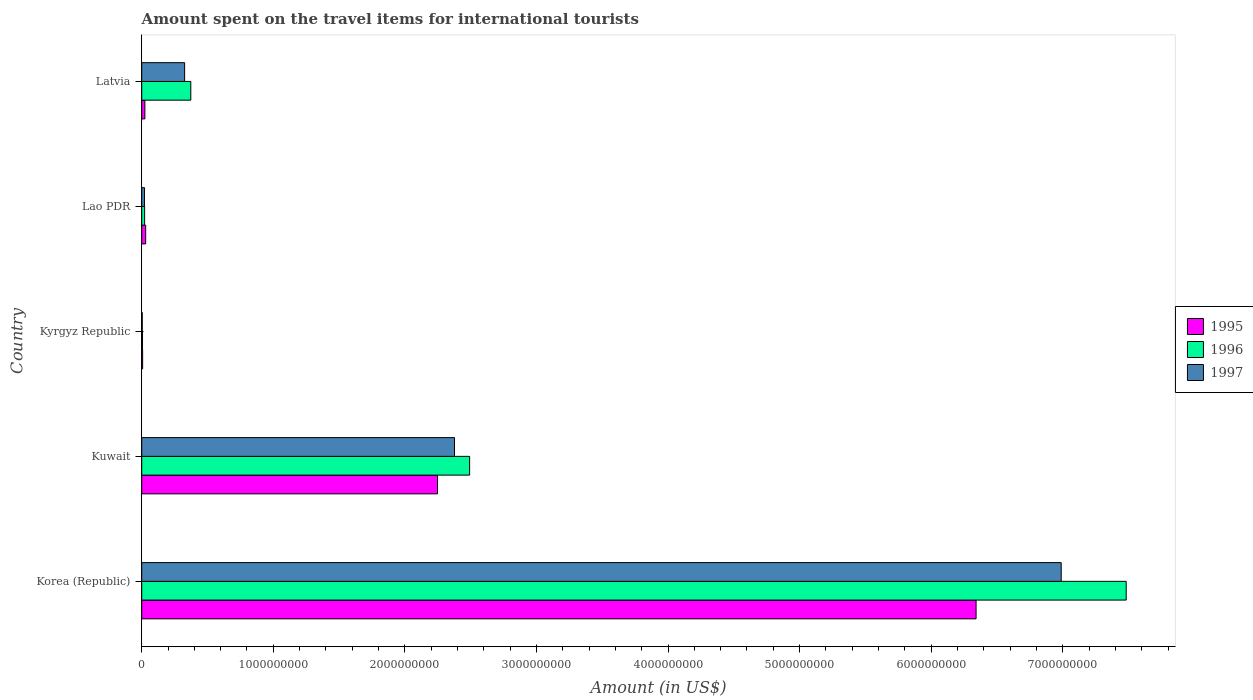How many different coloured bars are there?
Offer a terse response. 3. How many groups of bars are there?
Offer a very short reply. 5. Are the number of bars on each tick of the Y-axis equal?
Keep it short and to the point. Yes. How many bars are there on the 3rd tick from the top?
Provide a short and direct response. 3. What is the label of the 4th group of bars from the top?
Your response must be concise. Kuwait. What is the amount spent on the travel items for international tourists in 1997 in Kyrgyz Republic?
Keep it short and to the point. 4.00e+06. Across all countries, what is the maximum amount spent on the travel items for international tourists in 1996?
Offer a very short reply. 7.48e+09. Across all countries, what is the minimum amount spent on the travel items for international tourists in 1995?
Your answer should be very brief. 7.00e+06. In which country was the amount spent on the travel items for international tourists in 1997 maximum?
Your answer should be very brief. Korea (Republic). In which country was the amount spent on the travel items for international tourists in 1995 minimum?
Keep it short and to the point. Kyrgyz Republic. What is the total amount spent on the travel items for international tourists in 1995 in the graph?
Your response must be concise. 8.65e+09. What is the difference between the amount spent on the travel items for international tourists in 1996 in Kyrgyz Republic and that in Latvia?
Your answer should be compact. -3.67e+08. What is the difference between the amount spent on the travel items for international tourists in 1997 in Kuwait and the amount spent on the travel items for international tourists in 1995 in Latvia?
Provide a short and direct response. 2.35e+09. What is the average amount spent on the travel items for international tourists in 1995 per country?
Provide a succinct answer. 1.73e+09. What is the difference between the amount spent on the travel items for international tourists in 1997 and amount spent on the travel items for international tourists in 1995 in Kuwait?
Ensure brevity in your answer.  1.29e+08. In how many countries, is the amount spent on the travel items for international tourists in 1996 greater than 5200000000 US$?
Offer a terse response. 1. What is the ratio of the amount spent on the travel items for international tourists in 1995 in Kuwait to that in Lao PDR?
Ensure brevity in your answer.  74.93. Is the amount spent on the travel items for international tourists in 1996 in Kyrgyz Republic less than that in Latvia?
Provide a short and direct response. Yes. Is the difference between the amount spent on the travel items for international tourists in 1997 in Kuwait and Latvia greater than the difference between the amount spent on the travel items for international tourists in 1995 in Kuwait and Latvia?
Your answer should be compact. No. What is the difference between the highest and the second highest amount spent on the travel items for international tourists in 1995?
Give a very brief answer. 4.09e+09. What is the difference between the highest and the lowest amount spent on the travel items for international tourists in 1996?
Your answer should be very brief. 7.48e+09. In how many countries, is the amount spent on the travel items for international tourists in 1996 greater than the average amount spent on the travel items for international tourists in 1996 taken over all countries?
Make the answer very short. 2. What does the 1st bar from the bottom in Kuwait represents?
Provide a short and direct response. 1995. How many countries are there in the graph?
Keep it short and to the point. 5. What is the difference between two consecutive major ticks on the X-axis?
Keep it short and to the point. 1.00e+09. How are the legend labels stacked?
Offer a terse response. Vertical. What is the title of the graph?
Ensure brevity in your answer.  Amount spent on the travel items for international tourists. What is the label or title of the Y-axis?
Offer a terse response. Country. What is the Amount (in US$) of 1995 in Korea (Republic)?
Provide a short and direct response. 6.34e+09. What is the Amount (in US$) of 1996 in Korea (Republic)?
Provide a short and direct response. 7.48e+09. What is the Amount (in US$) in 1997 in Korea (Republic)?
Your answer should be compact. 6.99e+09. What is the Amount (in US$) in 1995 in Kuwait?
Your answer should be very brief. 2.25e+09. What is the Amount (in US$) in 1996 in Kuwait?
Ensure brevity in your answer.  2.49e+09. What is the Amount (in US$) in 1997 in Kuwait?
Your answer should be very brief. 2.38e+09. What is the Amount (in US$) in 1995 in Kyrgyz Republic?
Ensure brevity in your answer.  7.00e+06. What is the Amount (in US$) in 1996 in Kyrgyz Republic?
Your answer should be compact. 6.00e+06. What is the Amount (in US$) in 1997 in Kyrgyz Republic?
Your answer should be very brief. 4.00e+06. What is the Amount (in US$) of 1995 in Lao PDR?
Your response must be concise. 3.00e+07. What is the Amount (in US$) of 1996 in Lao PDR?
Keep it short and to the point. 2.20e+07. What is the Amount (in US$) of 1997 in Lao PDR?
Keep it short and to the point. 2.10e+07. What is the Amount (in US$) of 1995 in Latvia?
Offer a terse response. 2.40e+07. What is the Amount (in US$) of 1996 in Latvia?
Your response must be concise. 3.73e+08. What is the Amount (in US$) in 1997 in Latvia?
Offer a terse response. 3.26e+08. Across all countries, what is the maximum Amount (in US$) of 1995?
Your answer should be very brief. 6.34e+09. Across all countries, what is the maximum Amount (in US$) in 1996?
Offer a very short reply. 7.48e+09. Across all countries, what is the maximum Amount (in US$) in 1997?
Provide a short and direct response. 6.99e+09. Across all countries, what is the minimum Amount (in US$) of 1996?
Your response must be concise. 6.00e+06. What is the total Amount (in US$) in 1995 in the graph?
Your answer should be very brief. 8.65e+09. What is the total Amount (in US$) of 1996 in the graph?
Make the answer very short. 1.04e+1. What is the total Amount (in US$) in 1997 in the graph?
Ensure brevity in your answer.  9.72e+09. What is the difference between the Amount (in US$) of 1995 in Korea (Republic) and that in Kuwait?
Offer a very short reply. 4.09e+09. What is the difference between the Amount (in US$) in 1996 in Korea (Republic) and that in Kuwait?
Ensure brevity in your answer.  4.99e+09. What is the difference between the Amount (in US$) of 1997 in Korea (Republic) and that in Kuwait?
Provide a succinct answer. 4.61e+09. What is the difference between the Amount (in US$) in 1995 in Korea (Republic) and that in Kyrgyz Republic?
Keep it short and to the point. 6.33e+09. What is the difference between the Amount (in US$) of 1996 in Korea (Republic) and that in Kyrgyz Republic?
Provide a succinct answer. 7.48e+09. What is the difference between the Amount (in US$) in 1997 in Korea (Republic) and that in Kyrgyz Republic?
Give a very brief answer. 6.98e+09. What is the difference between the Amount (in US$) of 1995 in Korea (Republic) and that in Lao PDR?
Your response must be concise. 6.31e+09. What is the difference between the Amount (in US$) in 1996 in Korea (Republic) and that in Lao PDR?
Your answer should be very brief. 7.46e+09. What is the difference between the Amount (in US$) in 1997 in Korea (Republic) and that in Lao PDR?
Give a very brief answer. 6.97e+09. What is the difference between the Amount (in US$) in 1995 in Korea (Republic) and that in Latvia?
Give a very brief answer. 6.32e+09. What is the difference between the Amount (in US$) in 1996 in Korea (Republic) and that in Latvia?
Offer a terse response. 7.11e+09. What is the difference between the Amount (in US$) of 1997 in Korea (Republic) and that in Latvia?
Offer a very short reply. 6.66e+09. What is the difference between the Amount (in US$) in 1995 in Kuwait and that in Kyrgyz Republic?
Provide a succinct answer. 2.24e+09. What is the difference between the Amount (in US$) of 1996 in Kuwait and that in Kyrgyz Republic?
Provide a succinct answer. 2.49e+09. What is the difference between the Amount (in US$) of 1997 in Kuwait and that in Kyrgyz Republic?
Make the answer very short. 2.37e+09. What is the difference between the Amount (in US$) of 1995 in Kuwait and that in Lao PDR?
Make the answer very short. 2.22e+09. What is the difference between the Amount (in US$) in 1996 in Kuwait and that in Lao PDR?
Your answer should be very brief. 2.47e+09. What is the difference between the Amount (in US$) of 1997 in Kuwait and that in Lao PDR?
Your response must be concise. 2.36e+09. What is the difference between the Amount (in US$) of 1995 in Kuwait and that in Latvia?
Your answer should be compact. 2.22e+09. What is the difference between the Amount (in US$) of 1996 in Kuwait and that in Latvia?
Ensure brevity in your answer.  2.12e+09. What is the difference between the Amount (in US$) of 1997 in Kuwait and that in Latvia?
Make the answer very short. 2.05e+09. What is the difference between the Amount (in US$) of 1995 in Kyrgyz Republic and that in Lao PDR?
Offer a very short reply. -2.30e+07. What is the difference between the Amount (in US$) in 1996 in Kyrgyz Republic and that in Lao PDR?
Give a very brief answer. -1.60e+07. What is the difference between the Amount (in US$) in 1997 in Kyrgyz Republic and that in Lao PDR?
Give a very brief answer. -1.70e+07. What is the difference between the Amount (in US$) of 1995 in Kyrgyz Republic and that in Latvia?
Keep it short and to the point. -1.70e+07. What is the difference between the Amount (in US$) of 1996 in Kyrgyz Republic and that in Latvia?
Your answer should be compact. -3.67e+08. What is the difference between the Amount (in US$) in 1997 in Kyrgyz Republic and that in Latvia?
Give a very brief answer. -3.22e+08. What is the difference between the Amount (in US$) in 1995 in Lao PDR and that in Latvia?
Keep it short and to the point. 6.00e+06. What is the difference between the Amount (in US$) of 1996 in Lao PDR and that in Latvia?
Offer a very short reply. -3.51e+08. What is the difference between the Amount (in US$) in 1997 in Lao PDR and that in Latvia?
Your response must be concise. -3.05e+08. What is the difference between the Amount (in US$) of 1995 in Korea (Republic) and the Amount (in US$) of 1996 in Kuwait?
Give a very brief answer. 3.85e+09. What is the difference between the Amount (in US$) of 1995 in Korea (Republic) and the Amount (in US$) of 1997 in Kuwait?
Ensure brevity in your answer.  3.96e+09. What is the difference between the Amount (in US$) of 1996 in Korea (Republic) and the Amount (in US$) of 1997 in Kuwait?
Give a very brief answer. 5.10e+09. What is the difference between the Amount (in US$) in 1995 in Korea (Republic) and the Amount (in US$) in 1996 in Kyrgyz Republic?
Your answer should be compact. 6.34e+09. What is the difference between the Amount (in US$) in 1995 in Korea (Republic) and the Amount (in US$) in 1997 in Kyrgyz Republic?
Your answer should be very brief. 6.34e+09. What is the difference between the Amount (in US$) of 1996 in Korea (Republic) and the Amount (in US$) of 1997 in Kyrgyz Republic?
Your answer should be compact. 7.48e+09. What is the difference between the Amount (in US$) in 1995 in Korea (Republic) and the Amount (in US$) in 1996 in Lao PDR?
Make the answer very short. 6.32e+09. What is the difference between the Amount (in US$) in 1995 in Korea (Republic) and the Amount (in US$) in 1997 in Lao PDR?
Make the answer very short. 6.32e+09. What is the difference between the Amount (in US$) in 1996 in Korea (Republic) and the Amount (in US$) in 1997 in Lao PDR?
Provide a short and direct response. 7.46e+09. What is the difference between the Amount (in US$) in 1995 in Korea (Republic) and the Amount (in US$) in 1996 in Latvia?
Your answer should be compact. 5.97e+09. What is the difference between the Amount (in US$) in 1995 in Korea (Republic) and the Amount (in US$) in 1997 in Latvia?
Make the answer very short. 6.02e+09. What is the difference between the Amount (in US$) in 1996 in Korea (Republic) and the Amount (in US$) in 1997 in Latvia?
Offer a very short reply. 7.16e+09. What is the difference between the Amount (in US$) in 1995 in Kuwait and the Amount (in US$) in 1996 in Kyrgyz Republic?
Offer a very short reply. 2.24e+09. What is the difference between the Amount (in US$) in 1995 in Kuwait and the Amount (in US$) in 1997 in Kyrgyz Republic?
Provide a short and direct response. 2.24e+09. What is the difference between the Amount (in US$) of 1996 in Kuwait and the Amount (in US$) of 1997 in Kyrgyz Republic?
Your answer should be very brief. 2.49e+09. What is the difference between the Amount (in US$) in 1995 in Kuwait and the Amount (in US$) in 1996 in Lao PDR?
Make the answer very short. 2.23e+09. What is the difference between the Amount (in US$) of 1995 in Kuwait and the Amount (in US$) of 1997 in Lao PDR?
Ensure brevity in your answer.  2.23e+09. What is the difference between the Amount (in US$) of 1996 in Kuwait and the Amount (in US$) of 1997 in Lao PDR?
Your answer should be compact. 2.47e+09. What is the difference between the Amount (in US$) of 1995 in Kuwait and the Amount (in US$) of 1996 in Latvia?
Provide a succinct answer. 1.88e+09. What is the difference between the Amount (in US$) of 1995 in Kuwait and the Amount (in US$) of 1997 in Latvia?
Ensure brevity in your answer.  1.92e+09. What is the difference between the Amount (in US$) in 1996 in Kuwait and the Amount (in US$) in 1997 in Latvia?
Your answer should be compact. 2.17e+09. What is the difference between the Amount (in US$) of 1995 in Kyrgyz Republic and the Amount (in US$) of 1996 in Lao PDR?
Give a very brief answer. -1.50e+07. What is the difference between the Amount (in US$) in 1995 in Kyrgyz Republic and the Amount (in US$) in 1997 in Lao PDR?
Give a very brief answer. -1.40e+07. What is the difference between the Amount (in US$) of 1996 in Kyrgyz Republic and the Amount (in US$) of 1997 in Lao PDR?
Your response must be concise. -1.50e+07. What is the difference between the Amount (in US$) of 1995 in Kyrgyz Republic and the Amount (in US$) of 1996 in Latvia?
Offer a terse response. -3.66e+08. What is the difference between the Amount (in US$) of 1995 in Kyrgyz Republic and the Amount (in US$) of 1997 in Latvia?
Your answer should be compact. -3.19e+08. What is the difference between the Amount (in US$) in 1996 in Kyrgyz Republic and the Amount (in US$) in 1997 in Latvia?
Keep it short and to the point. -3.20e+08. What is the difference between the Amount (in US$) in 1995 in Lao PDR and the Amount (in US$) in 1996 in Latvia?
Make the answer very short. -3.43e+08. What is the difference between the Amount (in US$) of 1995 in Lao PDR and the Amount (in US$) of 1997 in Latvia?
Offer a very short reply. -2.96e+08. What is the difference between the Amount (in US$) in 1996 in Lao PDR and the Amount (in US$) in 1997 in Latvia?
Provide a succinct answer. -3.04e+08. What is the average Amount (in US$) of 1995 per country?
Your answer should be compact. 1.73e+09. What is the average Amount (in US$) in 1996 per country?
Your response must be concise. 2.08e+09. What is the average Amount (in US$) of 1997 per country?
Your answer should be compact. 1.94e+09. What is the difference between the Amount (in US$) in 1995 and Amount (in US$) in 1996 in Korea (Republic)?
Keep it short and to the point. -1.14e+09. What is the difference between the Amount (in US$) in 1995 and Amount (in US$) in 1997 in Korea (Republic)?
Provide a short and direct response. -6.47e+08. What is the difference between the Amount (in US$) of 1996 and Amount (in US$) of 1997 in Korea (Republic)?
Your response must be concise. 4.94e+08. What is the difference between the Amount (in US$) in 1995 and Amount (in US$) in 1996 in Kuwait?
Offer a very short reply. -2.44e+08. What is the difference between the Amount (in US$) in 1995 and Amount (in US$) in 1997 in Kuwait?
Your response must be concise. -1.29e+08. What is the difference between the Amount (in US$) in 1996 and Amount (in US$) in 1997 in Kuwait?
Make the answer very short. 1.15e+08. What is the difference between the Amount (in US$) of 1996 and Amount (in US$) of 1997 in Kyrgyz Republic?
Offer a terse response. 2.00e+06. What is the difference between the Amount (in US$) in 1995 and Amount (in US$) in 1997 in Lao PDR?
Make the answer very short. 9.00e+06. What is the difference between the Amount (in US$) of 1996 and Amount (in US$) of 1997 in Lao PDR?
Give a very brief answer. 1.00e+06. What is the difference between the Amount (in US$) in 1995 and Amount (in US$) in 1996 in Latvia?
Offer a terse response. -3.49e+08. What is the difference between the Amount (in US$) in 1995 and Amount (in US$) in 1997 in Latvia?
Ensure brevity in your answer.  -3.02e+08. What is the difference between the Amount (in US$) in 1996 and Amount (in US$) in 1997 in Latvia?
Provide a succinct answer. 4.70e+07. What is the ratio of the Amount (in US$) in 1995 in Korea (Republic) to that in Kuwait?
Keep it short and to the point. 2.82. What is the ratio of the Amount (in US$) of 1996 in Korea (Republic) to that in Kuwait?
Keep it short and to the point. 3. What is the ratio of the Amount (in US$) in 1997 in Korea (Republic) to that in Kuwait?
Offer a very short reply. 2.94. What is the ratio of the Amount (in US$) in 1995 in Korea (Republic) to that in Kyrgyz Republic?
Provide a short and direct response. 905.86. What is the ratio of the Amount (in US$) in 1996 in Korea (Republic) to that in Kyrgyz Republic?
Your answer should be very brief. 1247. What is the ratio of the Amount (in US$) in 1997 in Korea (Republic) to that in Kyrgyz Republic?
Give a very brief answer. 1747. What is the ratio of the Amount (in US$) in 1995 in Korea (Republic) to that in Lao PDR?
Offer a very short reply. 211.37. What is the ratio of the Amount (in US$) of 1996 in Korea (Republic) to that in Lao PDR?
Your answer should be compact. 340.09. What is the ratio of the Amount (in US$) of 1997 in Korea (Republic) to that in Lao PDR?
Make the answer very short. 332.76. What is the ratio of the Amount (in US$) in 1995 in Korea (Republic) to that in Latvia?
Provide a succinct answer. 264.21. What is the ratio of the Amount (in US$) of 1996 in Korea (Republic) to that in Latvia?
Your answer should be compact. 20.06. What is the ratio of the Amount (in US$) in 1997 in Korea (Republic) to that in Latvia?
Keep it short and to the point. 21.44. What is the ratio of the Amount (in US$) in 1995 in Kuwait to that in Kyrgyz Republic?
Give a very brief answer. 321.14. What is the ratio of the Amount (in US$) in 1996 in Kuwait to that in Kyrgyz Republic?
Keep it short and to the point. 415.33. What is the ratio of the Amount (in US$) in 1997 in Kuwait to that in Kyrgyz Republic?
Your response must be concise. 594.25. What is the ratio of the Amount (in US$) in 1995 in Kuwait to that in Lao PDR?
Keep it short and to the point. 74.93. What is the ratio of the Amount (in US$) of 1996 in Kuwait to that in Lao PDR?
Make the answer very short. 113.27. What is the ratio of the Amount (in US$) in 1997 in Kuwait to that in Lao PDR?
Ensure brevity in your answer.  113.19. What is the ratio of the Amount (in US$) in 1995 in Kuwait to that in Latvia?
Keep it short and to the point. 93.67. What is the ratio of the Amount (in US$) of 1996 in Kuwait to that in Latvia?
Provide a succinct answer. 6.68. What is the ratio of the Amount (in US$) in 1997 in Kuwait to that in Latvia?
Your answer should be compact. 7.29. What is the ratio of the Amount (in US$) in 1995 in Kyrgyz Republic to that in Lao PDR?
Ensure brevity in your answer.  0.23. What is the ratio of the Amount (in US$) of 1996 in Kyrgyz Republic to that in Lao PDR?
Your answer should be very brief. 0.27. What is the ratio of the Amount (in US$) in 1997 in Kyrgyz Republic to that in Lao PDR?
Your response must be concise. 0.19. What is the ratio of the Amount (in US$) in 1995 in Kyrgyz Republic to that in Latvia?
Give a very brief answer. 0.29. What is the ratio of the Amount (in US$) in 1996 in Kyrgyz Republic to that in Latvia?
Offer a very short reply. 0.02. What is the ratio of the Amount (in US$) of 1997 in Kyrgyz Republic to that in Latvia?
Give a very brief answer. 0.01. What is the ratio of the Amount (in US$) in 1996 in Lao PDR to that in Latvia?
Offer a very short reply. 0.06. What is the ratio of the Amount (in US$) in 1997 in Lao PDR to that in Latvia?
Your answer should be compact. 0.06. What is the difference between the highest and the second highest Amount (in US$) in 1995?
Keep it short and to the point. 4.09e+09. What is the difference between the highest and the second highest Amount (in US$) in 1996?
Offer a very short reply. 4.99e+09. What is the difference between the highest and the second highest Amount (in US$) in 1997?
Offer a very short reply. 4.61e+09. What is the difference between the highest and the lowest Amount (in US$) in 1995?
Your answer should be very brief. 6.33e+09. What is the difference between the highest and the lowest Amount (in US$) in 1996?
Your response must be concise. 7.48e+09. What is the difference between the highest and the lowest Amount (in US$) in 1997?
Your answer should be very brief. 6.98e+09. 